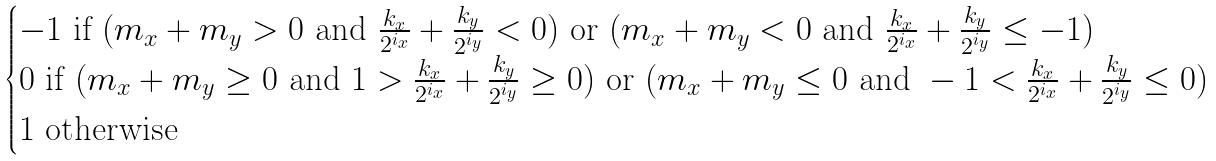Convert formula to latex. <formula><loc_0><loc_0><loc_500><loc_500>\begin{cases} - 1 \text { if } ( m _ { x } + m _ { y } > 0 \text { and } \frac { k _ { x } } { 2 ^ { i _ { x } } } + \frac { k _ { y } } { 2 ^ { i _ { y } } } < 0 ) \text { or } ( m _ { x } + m _ { y } < 0 \text { and } \frac { k _ { x } } { 2 ^ { i _ { x } } } + \frac { k _ { y } } { 2 ^ { i _ { y } } } \leq - 1 ) \\ 0 \text { if } ( m _ { x } + m _ { y } \geq 0 \text { and } 1 > \frac { k _ { x } } { 2 ^ { i _ { x } } } + \frac { k _ { y } } { 2 ^ { i _ { y } } } \geq 0 ) \text { or } ( m _ { x } + m _ { y } \leq 0 \text { and } - 1 < \frac { k _ { x } } { 2 ^ { i _ { x } } } + \frac { k _ { y } } { 2 ^ { i _ { y } } } \leq 0 ) \\ 1 \text { otherwise } \end{cases}</formula> 